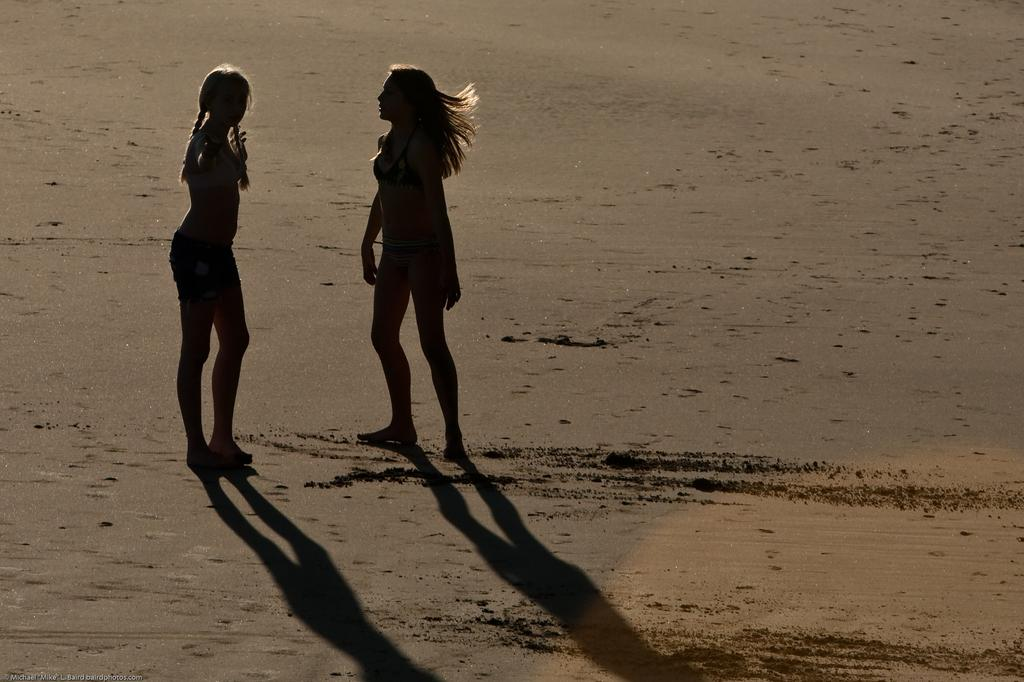How many people are present in the image? There are two persons standing in the image. What can be seen in the background of the image? There is sand visible in the background of the image. What type of stitch is being used to sew the sand in the image? There is no stitching or sewing present in the image; it features two persons standing in front of sand. 